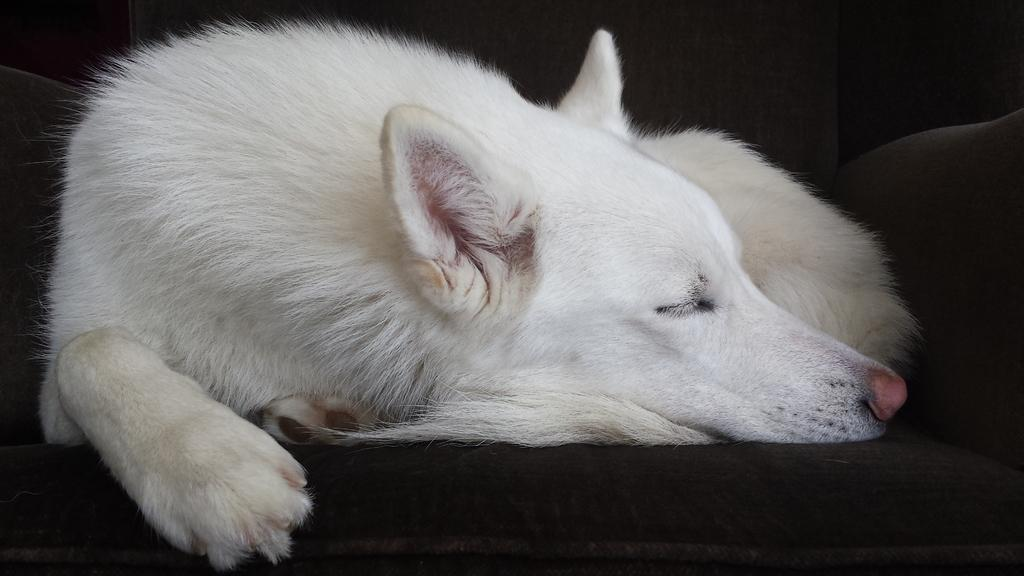What type of animal is in the image? There is a white color dog in the image. What is the dog doing in the image? The dog is lying on a sofa. Where is the dog located in the image? The dog is in the middle of the image. What type of bag is the dog carrying in the image? There is no bag present in the image; the dog is lying on a sofa. What nation does the dog represent in the image? The image does not depict the dog representing any nation. 